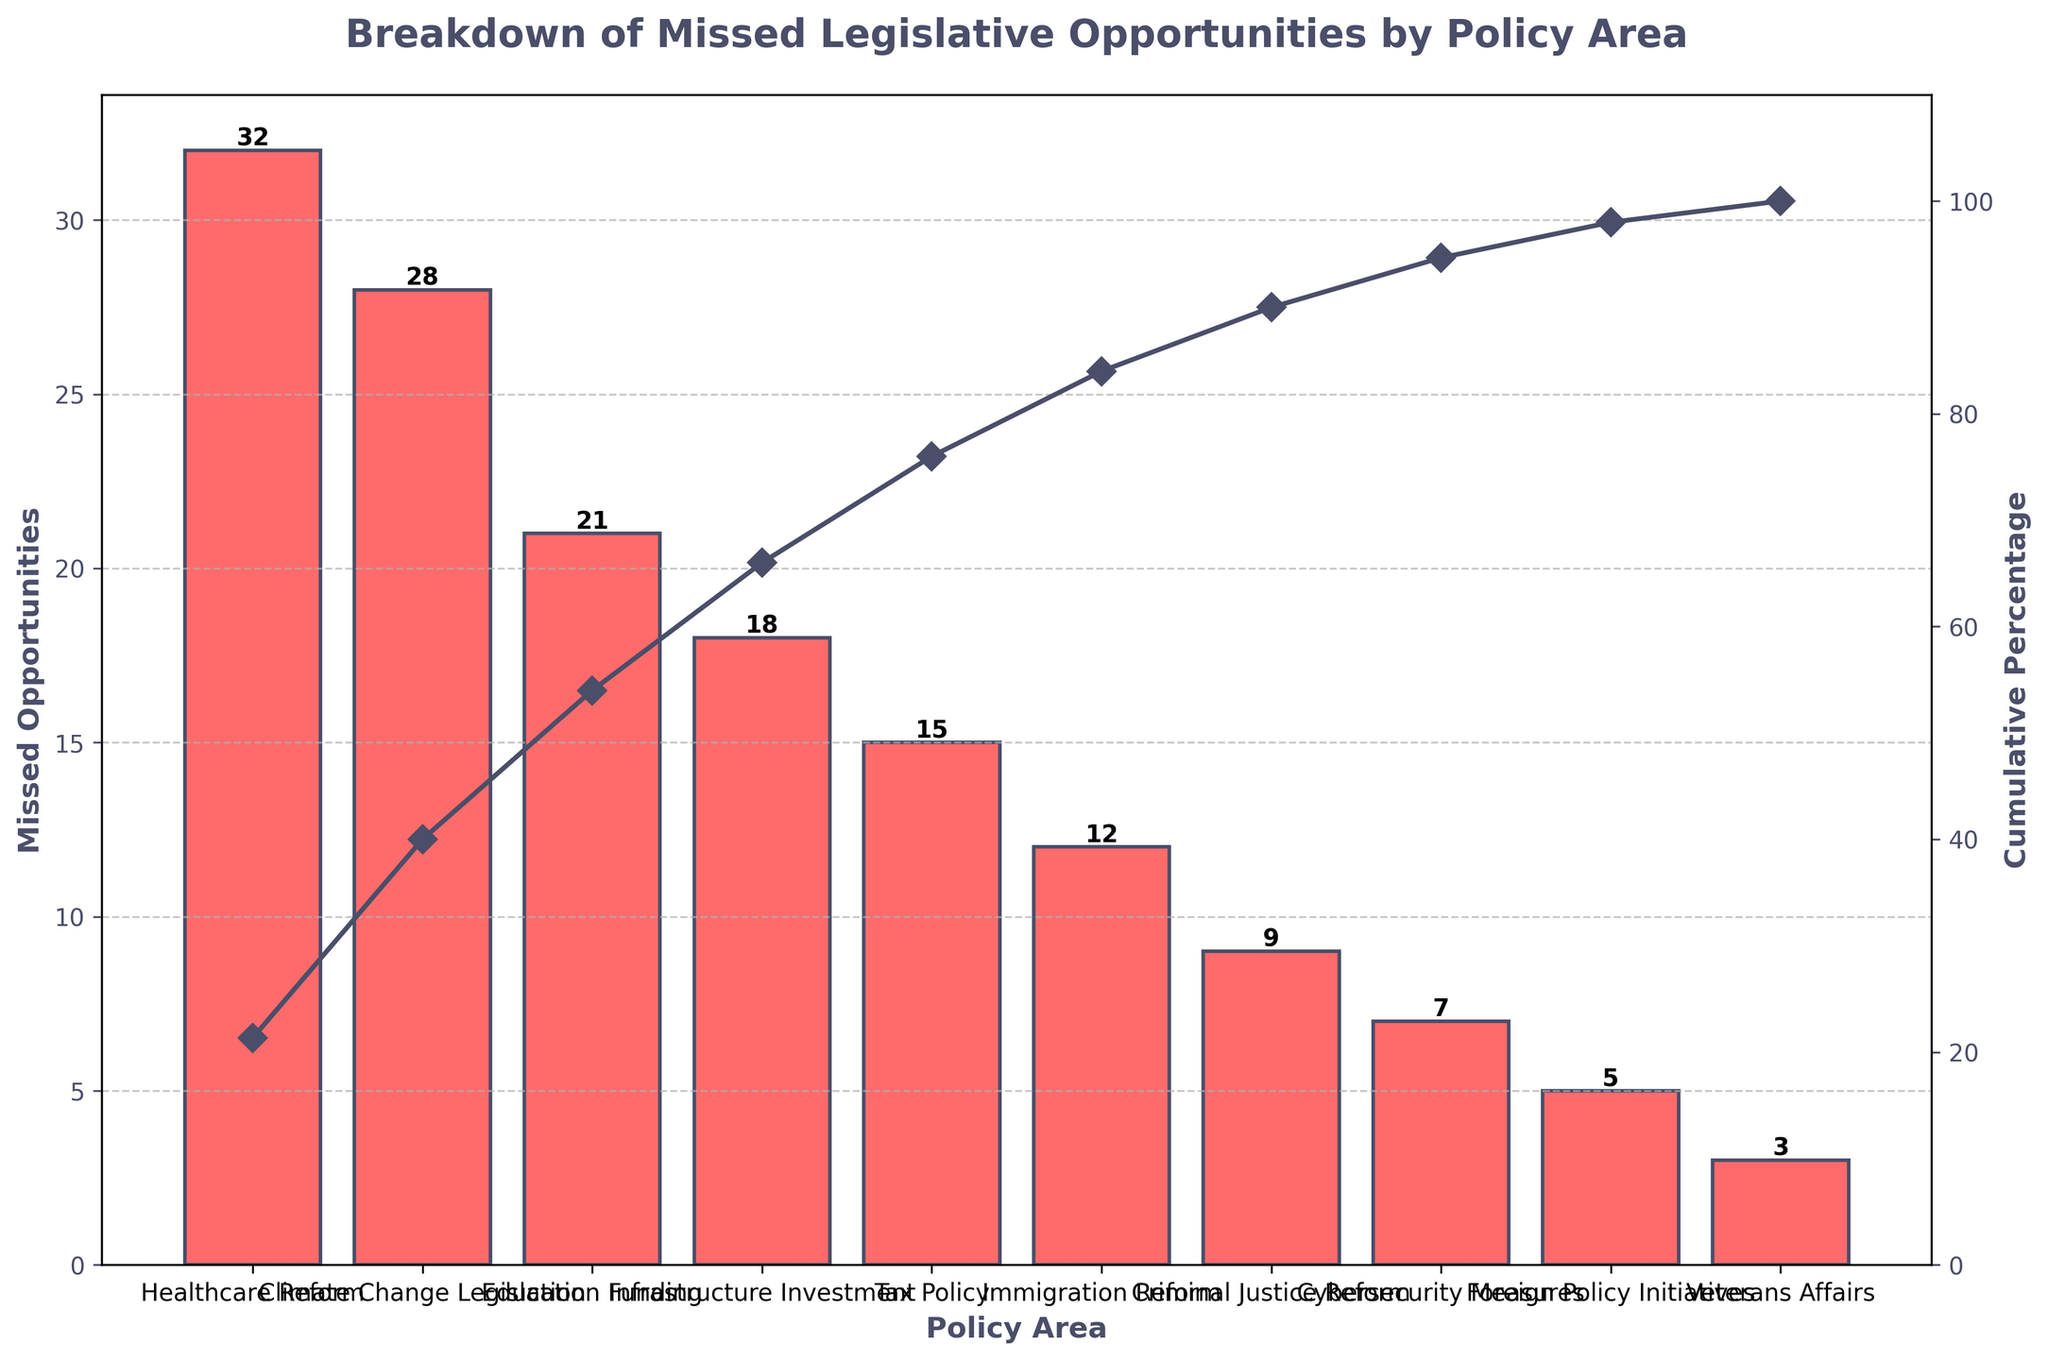what is the title of the plot? The title is usually found at the top of the plot and describes what the visualization represents. Here, it mentions "Breakdown of Missed Legislative Opportunities by Policy Area". This title is bold and specifically outlines the content focus of the chart, giving us a direct indicator of what the chart is about.
Answer: Breakdown of Missed Legislative Opportunities by Policy Area how many policy areas are represented in the plot? The number of policy areas can be determined by counting the bars in the bar chart or the labels on the x-axis. In this chart, each bar corresponds to a different policy area, making it easy to count. By counting the bars, we will know the number of distinct policy areas represented.
Answer: 10 which policy area has the highest number of missed opportunities? The policy area with the highest number of missed opportunities can be identified by finding the tallest bar in the bar chart. In this chart, the healthcare reform bar is the tallest, indicating it has the highest count.
Answer: Healthcare Reform what is the cumulative percentage of missed opportunities up to and including education funding? The cumulative percentage plot line helps us see how the percentages add up as we move across different policy areas. For this question, locate the point on the cumulative line corresponding to Education Funding. The percentage value at this point gives the required cumulative percentage.
Answer: 60.1% what is the difference in missed opportunities between healthcare reform and infrastructure investment? To find the difference, look at the heights of the bars for Healthcare Reform (32) and Infrastructure Investment (18). Subtract the smaller number from the larger one to get the difference: 32 - 18 = 14.
Answer: 14 which two policy areas have the smallest number of missed opportunities, and what are their counts? Examine the plot to identify the two shortest bars, which reflect the smallest numbers of missed opportunities. Those are the bars for Veterans Affairs and Foreign Policy Initiatives. The counts for these are shown at the top of the respective bars.
Answer: Veterans Affairs (3) and Foreign Policy Initiatives (5) are there more missed opportunities in climate change legislation than in tax policy? Comparison questions like this require us to compare the heights of the respective bars. Here, compare the bar for Climate Change Legislation with the one for Tax Policy. The heights indicate the respective counts: Climate Change (28) and Tax Policy (15). Since 28 is greater than 15, the answer is yes.
Answer: Yes what is the cumulative percentage of missed opportunities represented by the top four policy areas? To solve this, look at the cumulative percentage line and find the value at the point that includes up to the fourth policy area from the left. The fourth policy area here is Infrastructure Investment. The cumulative percentage at this point is approximately 83.1%.
Answer: 83.1% how much lower is the number of missed opportunities in immigration reform compared to criminal justice reform? Find the heights of the bars corresponding to Immigration Reform (12) and Criminal Justice Reform (9). Subtract the number for Criminal Justice Reform from that for Immigration Reform to get the difference, which is 12 - 9 = 3.
Answer: 3 which policy areas contribute to at least 80% of the missed opportunities? Identify the bars that collectively reach or surpass 80% on the cumulative percentage line. The cumulative curve indicates that Healthcare Reform, Climate Change Legislation, Education Funding, and Infrastructure Investment together just exceed 80%.
Answer: Healthcare Reform, Climate Change Legislation, Education Funding, and Infrastructure Investment 